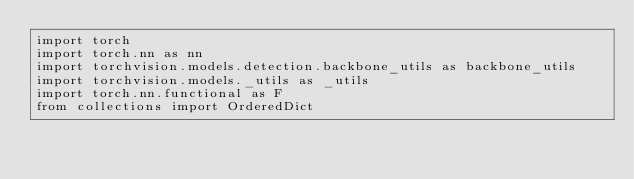<code> <loc_0><loc_0><loc_500><loc_500><_Python_>import torch
import torch.nn as nn
import torchvision.models.detection.backbone_utils as backbone_utils
import torchvision.models._utils as _utils
import torch.nn.functional as F
from collections import OrderedDict
</code> 